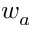<formula> <loc_0><loc_0><loc_500><loc_500>w _ { a }</formula> 